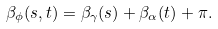Convert formula to latex. <formula><loc_0><loc_0><loc_500><loc_500>\beta _ { \phi } ( s , t ) = \beta _ { \gamma } ( s ) + \beta _ { \alpha } ( t ) + \pi .</formula> 